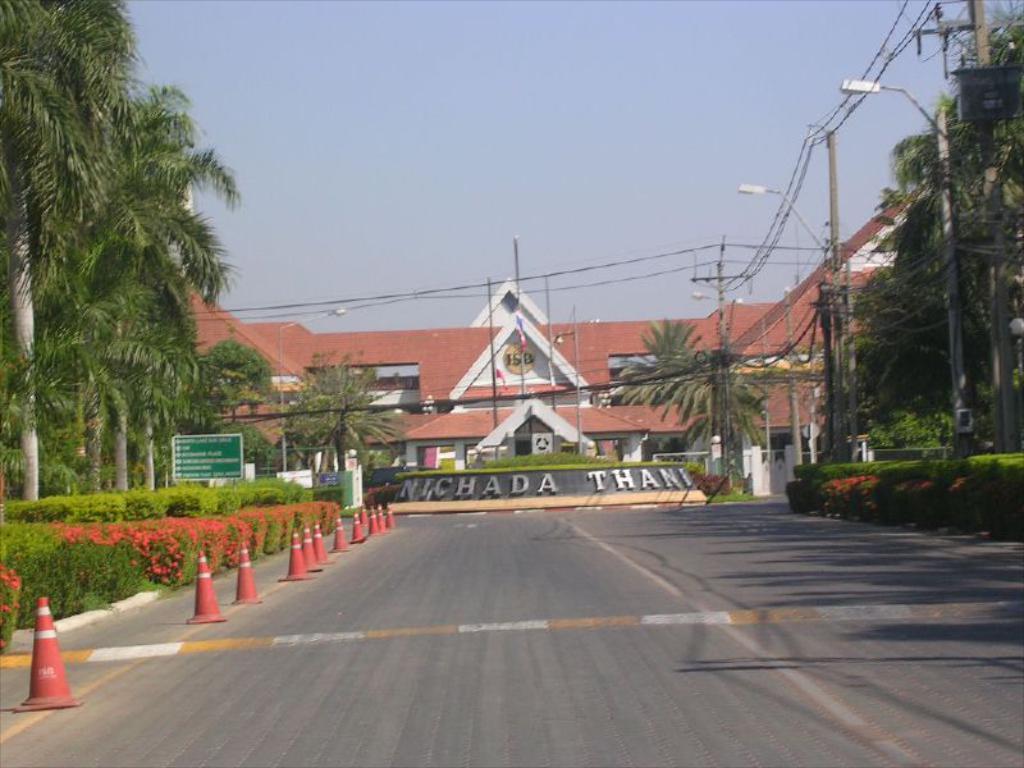Could you give a brief overview of what you see in this image? In this image I can see the road. To the left there are the traffic cones. To the side of the road. I can see many plants and trees. In the back I can see the building which is in brown color. And I can see the name written on it. I can also see the wires and sky in the back. 